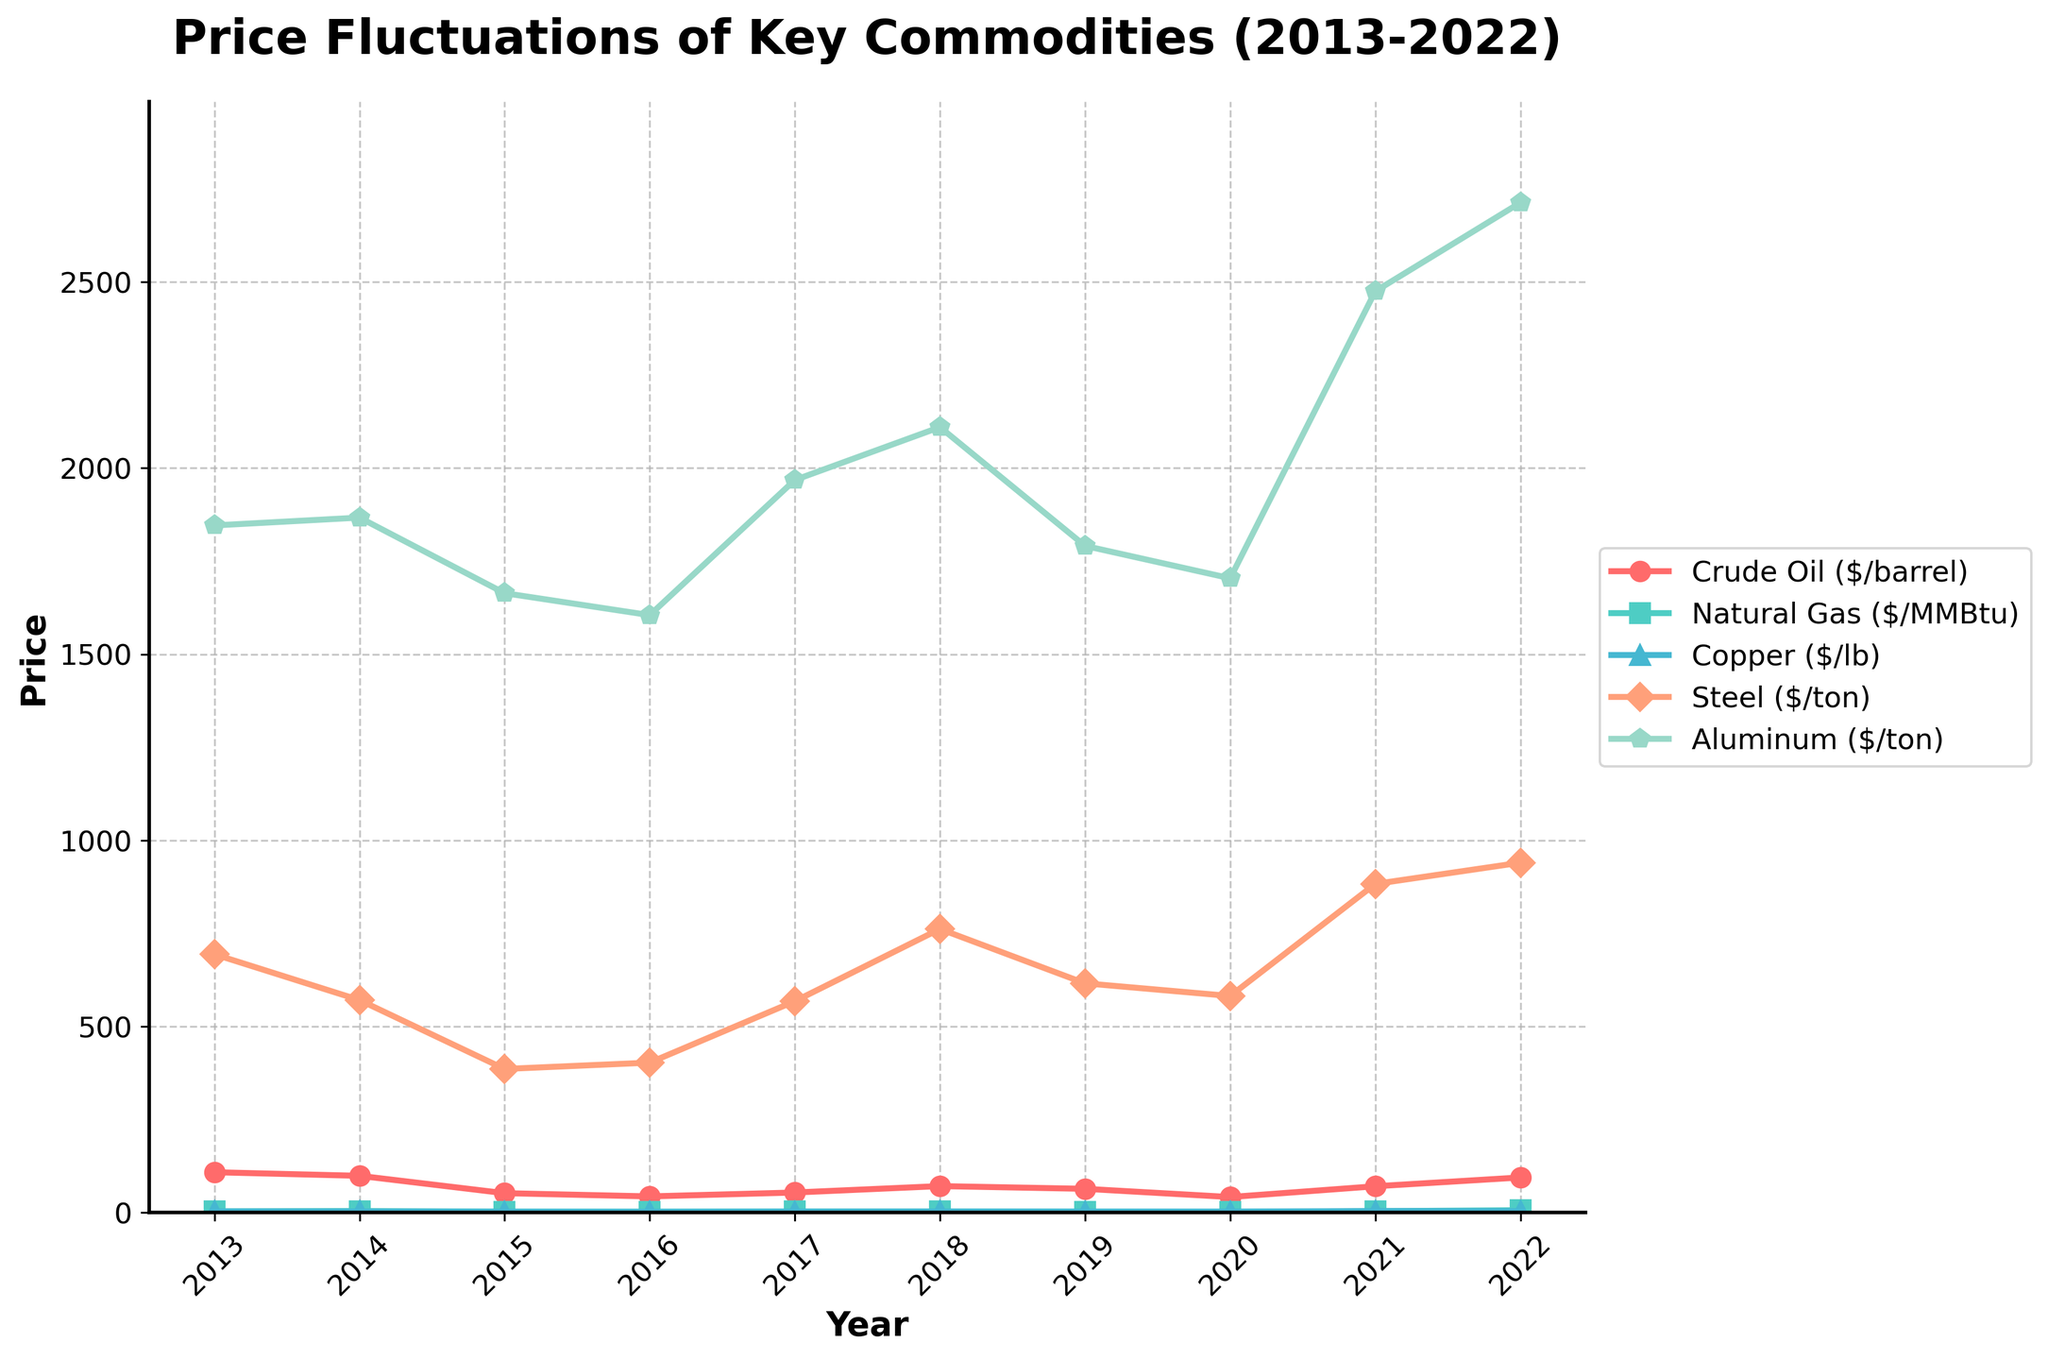How did the price of Crude Oil change from 2013 to 2022? To find the price change of Crude Oil from 2013 to 2022, subtract the price in 2013 from the price in 2022: 94.53 - 108.56 = -14.03
Answer: -14.03 Which commodity had the most stable price during the last decade? A visual inspection of the chart shows that Natural Gas prices had smaller fluctuations compared to other commodities. The general trend appears more consistent, without extreme highs or lows.
Answer: Natural Gas In which year did Steel have its highest price? Look for the highest point on the Steel price line. The year when this occurred was 2022, where the Steel price was 940.
Answer: 2022 By how much did the price of Aluminum increase between 2020 and 2022? Subtract the price of Aluminum in 2020 from its price in 2022: 2713 - 1704 = 1009
Answer: 1009 How many times did the price of Natural Gas exceed $4.00/MMBtu over the decade? By examining the Natural Gas line, we see that it exceeded $4.00/MMBtu in 2014, 2021, and 2022. This happened 3 times.
Answer: 3 Did the price of Copper ever surpass $4.00 per lb in the last decade? Looking at the Copper line, it surpassed $4.00/lb in 2021 and had a price of 4.23. It did not exceed $4.00/lb in any other year.
Answer: Yes Which commodity had the highest price variability? The highest variability can be visually inferred from the commodities' price lines with the widest range of fluctuations. Crude Oil shows the highest variability, especially with a peak price in 2013 and a significant drop in 2016.
Answer: Crude Oil What was the average price of Steel from 2013 to 2022? Calculate the average of Steel prices from 2013 to 2022: (694 + 571 + 386 + 403 + 568 + 762 + 616 + 582 + 883 + 940)/10 = 640.5
Answer: 640.5 Which commodity experienced the largest price increase between any two consecutive years? Examine the chart for the steepest positive slope between any two consecutive years. Natural Gas had a significant increase from 2021 to 2022, rising from 3.91 to 6.45, an increase of 2.54.
Answer: Natural Gas 